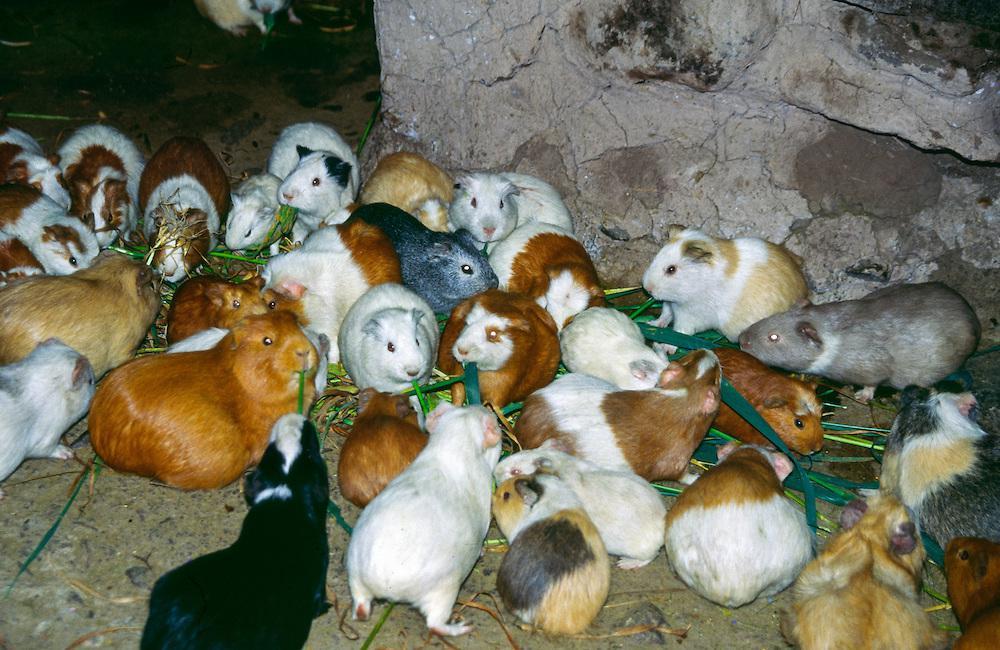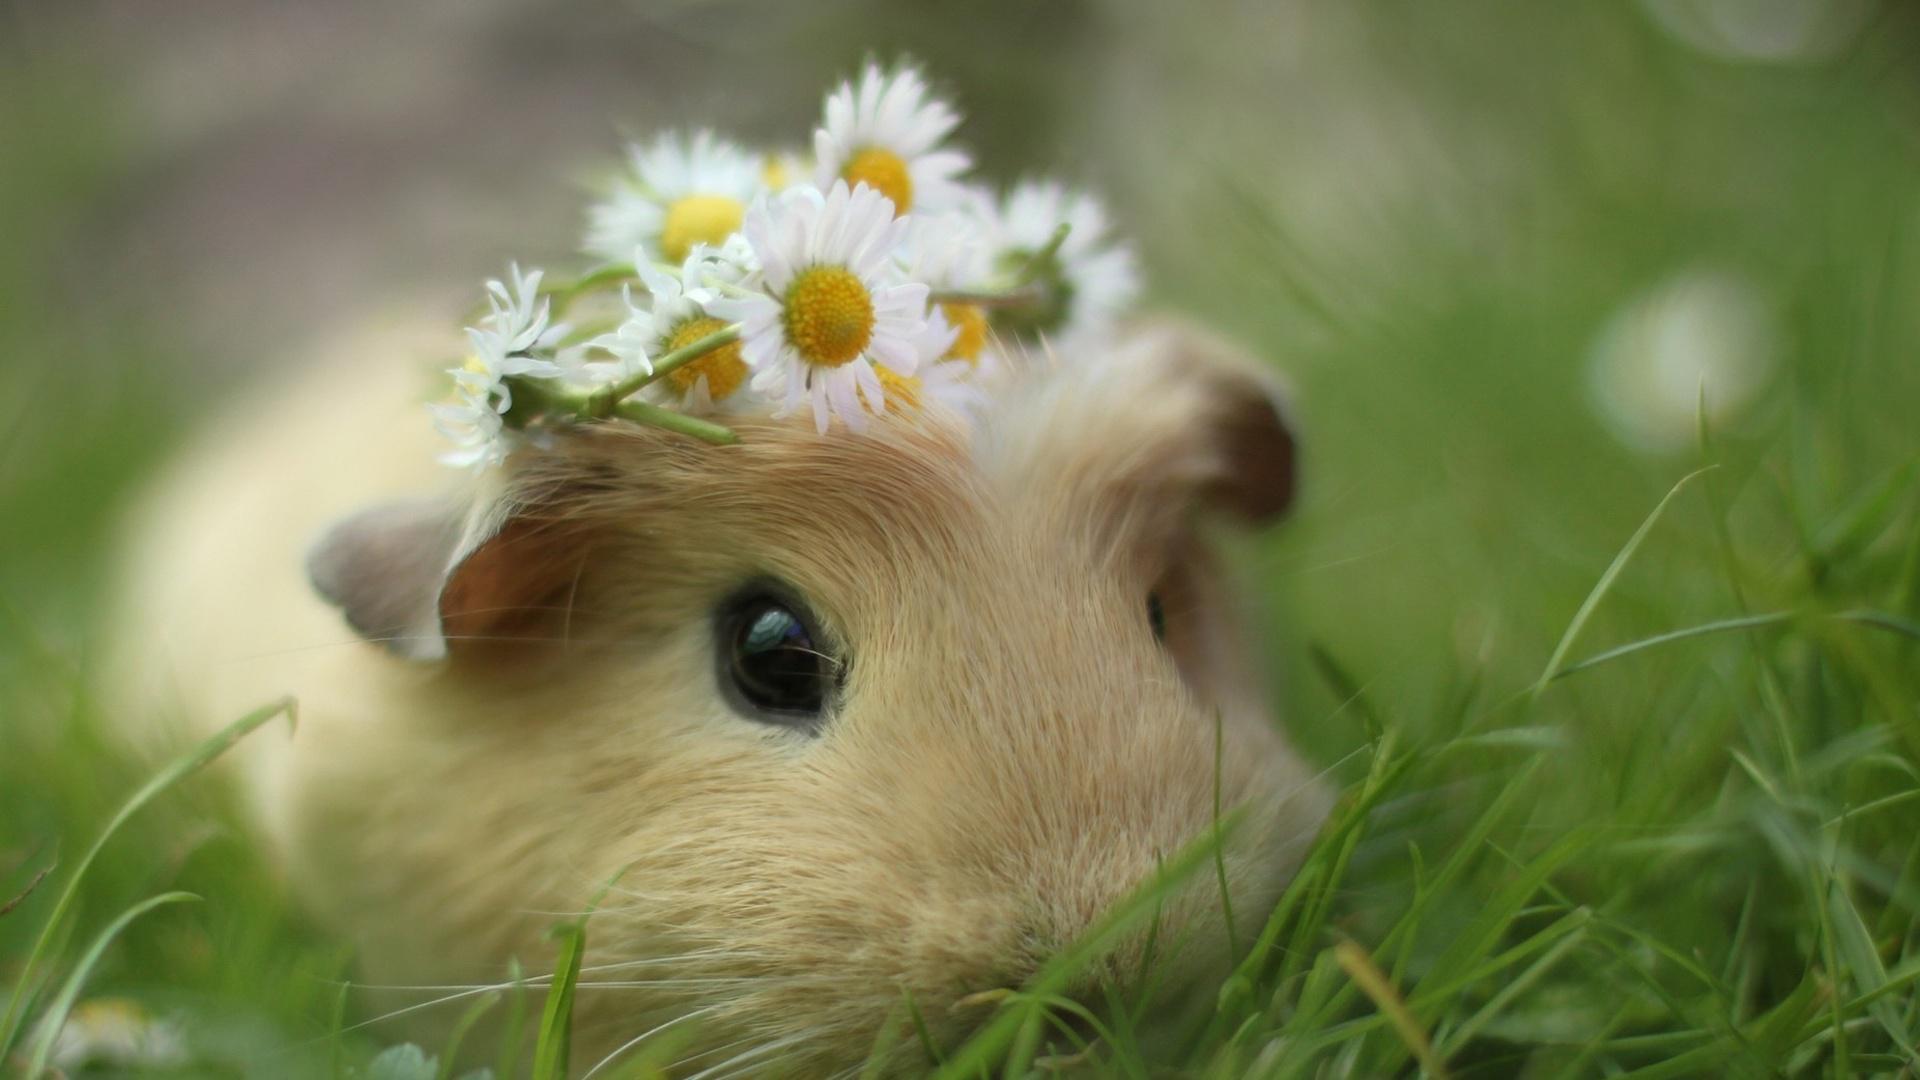The first image is the image on the left, the second image is the image on the right. Considering the images on both sides, is "There is a total of 1 guinea pig being displayed with flowers." valid? Answer yes or no. Yes. 